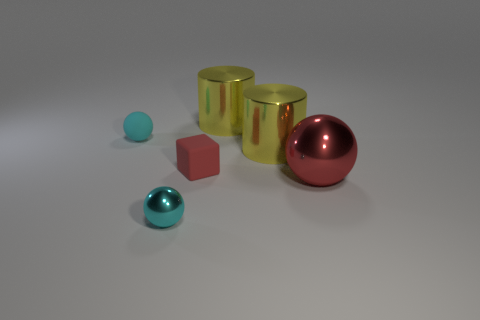Add 4 small brown things. How many objects exist? 10 Subtract all cylinders. How many objects are left? 4 Add 3 tiny green cylinders. How many tiny green cylinders exist? 3 Subtract 0 yellow cubes. How many objects are left? 6 Subtract all blue rubber things. Subtract all small cyan things. How many objects are left? 4 Add 6 small objects. How many small objects are left? 9 